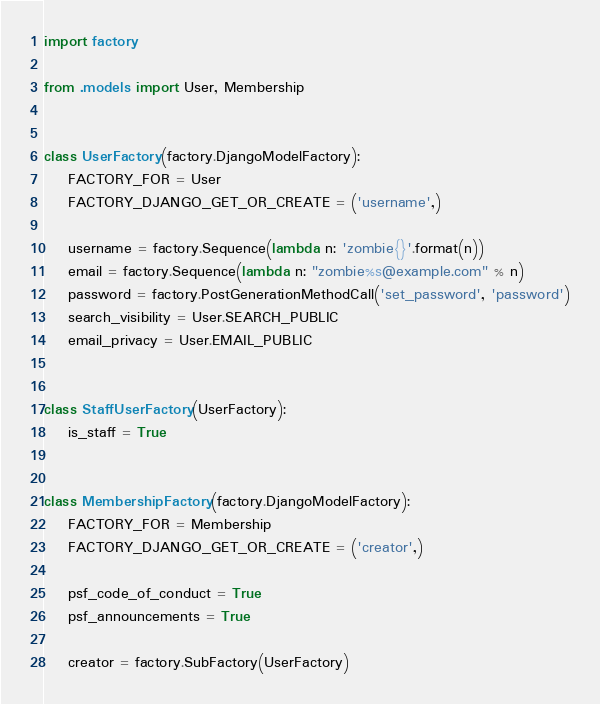<code> <loc_0><loc_0><loc_500><loc_500><_Python_>import factory

from .models import User, Membership


class UserFactory(factory.DjangoModelFactory):
    FACTORY_FOR = User
    FACTORY_DJANGO_GET_OR_CREATE = ('username',)

    username = factory.Sequence(lambda n: 'zombie{}'.format(n))
    email = factory.Sequence(lambda n: "zombie%s@example.com" % n)
    password = factory.PostGenerationMethodCall('set_password', 'password')
    search_visibility = User.SEARCH_PUBLIC
    email_privacy = User.EMAIL_PUBLIC


class StaffUserFactory(UserFactory):
    is_staff = True


class MembershipFactory(factory.DjangoModelFactory):
    FACTORY_FOR = Membership
    FACTORY_DJANGO_GET_OR_CREATE = ('creator',)

    psf_code_of_conduct = True
    psf_announcements = True

    creator = factory.SubFactory(UserFactory)
</code> 